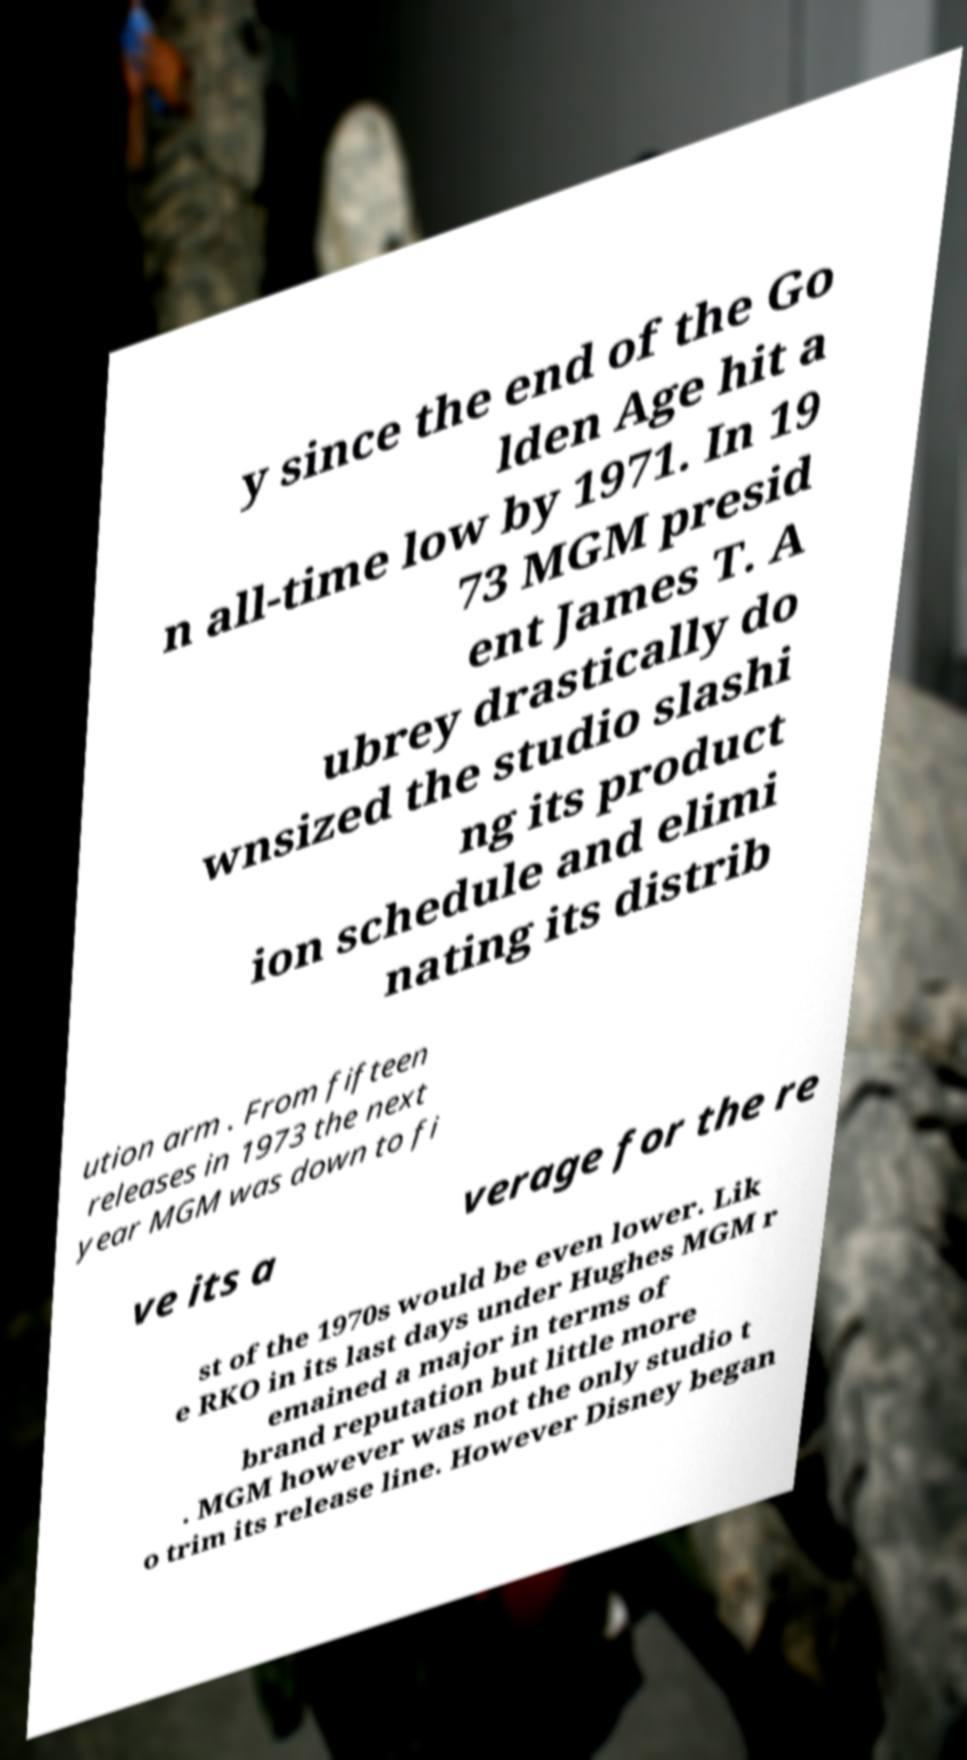What messages or text are displayed in this image? I need them in a readable, typed format. y since the end of the Go lden Age hit a n all-time low by 1971. In 19 73 MGM presid ent James T. A ubrey drastically do wnsized the studio slashi ng its product ion schedule and elimi nating its distrib ution arm . From fifteen releases in 1973 the next year MGM was down to fi ve its a verage for the re st of the 1970s would be even lower. Lik e RKO in its last days under Hughes MGM r emained a major in terms of brand reputation but little more . MGM however was not the only studio t o trim its release line. However Disney began 